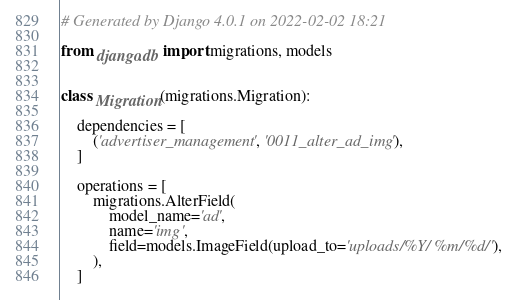Convert code to text. <code><loc_0><loc_0><loc_500><loc_500><_Python_># Generated by Django 4.0.1 on 2022-02-02 18:21

from django.db import migrations, models


class Migration(migrations.Migration):

    dependencies = [
        ('advertiser_management', '0011_alter_ad_img'),
    ]

    operations = [
        migrations.AlterField(
            model_name='ad',
            name='img',
            field=models.ImageField(upload_to='uploads/%Y/%m/%d/'),
        ),
    ]
</code> 